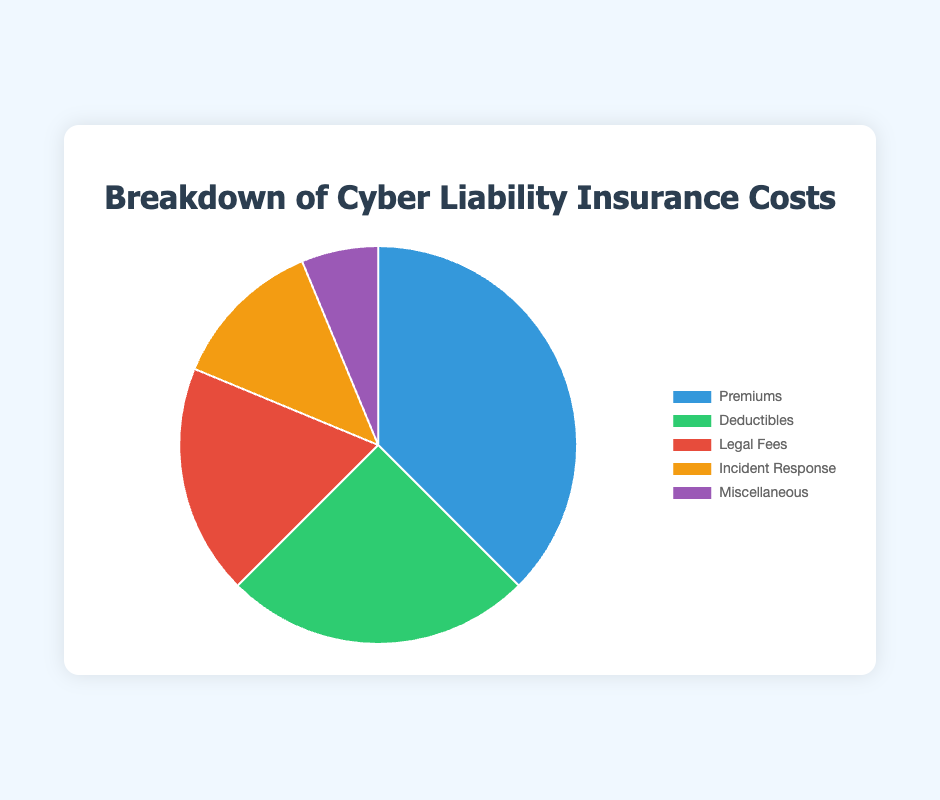Which category has the highest cost? The chart shows different categories with their corresponding costs. The category with the highest cost should be the largest slice in the pie chart. In this case, the "Premiums" category has the highest cost.
Answer: Premiums How much more do Premiums cost compared to Deductibles? To find the difference in cost between the Premiums and Deductibles categories, subtract the Deductibles cost from the Premiums cost: $3000 - $2000 = $1000.
Answer: $1000 What is the total cost of Legal Fees and Incident Response combined? Add the costs for Legal Fees and Incident Response: $1500 + $1000 = $2500.
Answer: $2500 Which category costs the least? The smallest slice in the pie chart corresponds to the category with the least cost, which is "Miscellaneous".
Answer: Miscellaneous What fraction of the total cost is due to Deductibles? First, find the total cost by summing all the category costs: $3000 + $2000 + $1500 + $1000 + $500 = $8000. Then, divide the Deductibles cost by the total cost: $2000 / $8000 = 0.25, which is 25%.
Answer: 25% How much more do Premiums and Deductibles combined cost compared to Legal Fees? First, find the combined cost for Premiums and Deductibles: $3000 + $2000 = $5000. Then, subtract the cost of Legal Fees from this combined cost: $5000 - $1500 = $3500.
Answer: $3500 What percentage of the total cost is attributed to Miscellaneous and Incident Response together? First, find the total cost: $8000. Then, find the combined cost of Miscellaneous and Incident Response: $500 + $1000 = $1500. Finally, calculate the percentage: ($1500 / $8000) * 100% = 18.75%.
Answer: 18.75% What is the average cost per category? To find the average cost, divide the total cost by the number of categories: $8000 / 5 = $1600.
Answer: $1600 